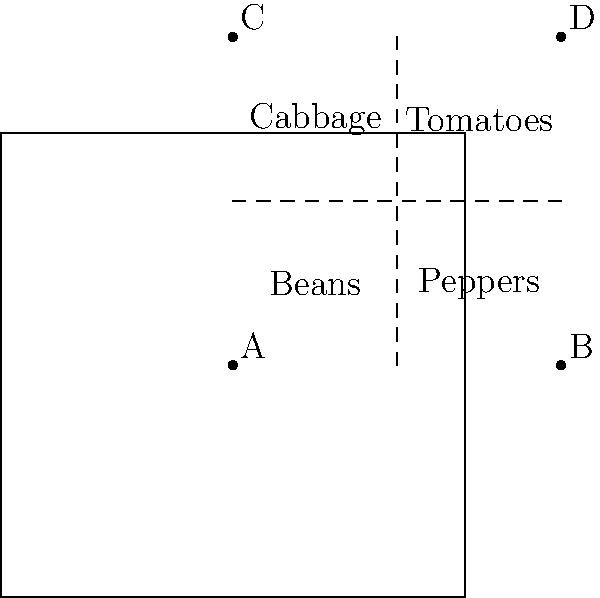In your small vegetable garden plot, you want to plant cabbage, tomatoes, beans, and peppers. The plot is divided into four equal sections as shown. Which arrangement of vegetables would be most efficient, considering that tomatoes need more sunlight and should be planted on the east side (right side of the diagram), while cabbage prefers cooler temperatures and should be on the north side (top of the diagram)? To determine the most efficient layout, let's follow these steps:

1. Identify the constraints:
   - Tomatoes need more sunlight and should be on the east (right) side
   - Cabbage prefers cooler temperatures and should be on the north (top) side

2. Based on these constraints:
   - Cabbage must be in section C (top-left)
   - Tomatoes must be in either section B or D (right side)

3. Consider the remaining vegetables:
   - Beans and peppers have no specific requirements mentioned

4. Optimal arrangement:
   - Place cabbage in section C (satisfies the north side requirement)
   - Place tomatoes in section D (satisfies the east side requirement and gives them the most sun exposure in the southeast corner)
   - Place beans in section A (no specific requirements)
   - Place peppers in section B (no specific requirements)

5. The final arrangement from top-left, clockwise:
   Cabbage (C), Tomatoes (D), Peppers (B), Beans (A)

This arrangement satisfies all the given constraints and provides an efficient use of the available space based on each plant's needs.
Answer: C: Cabbage, D: Tomatoes, B: Peppers, A: Beans 